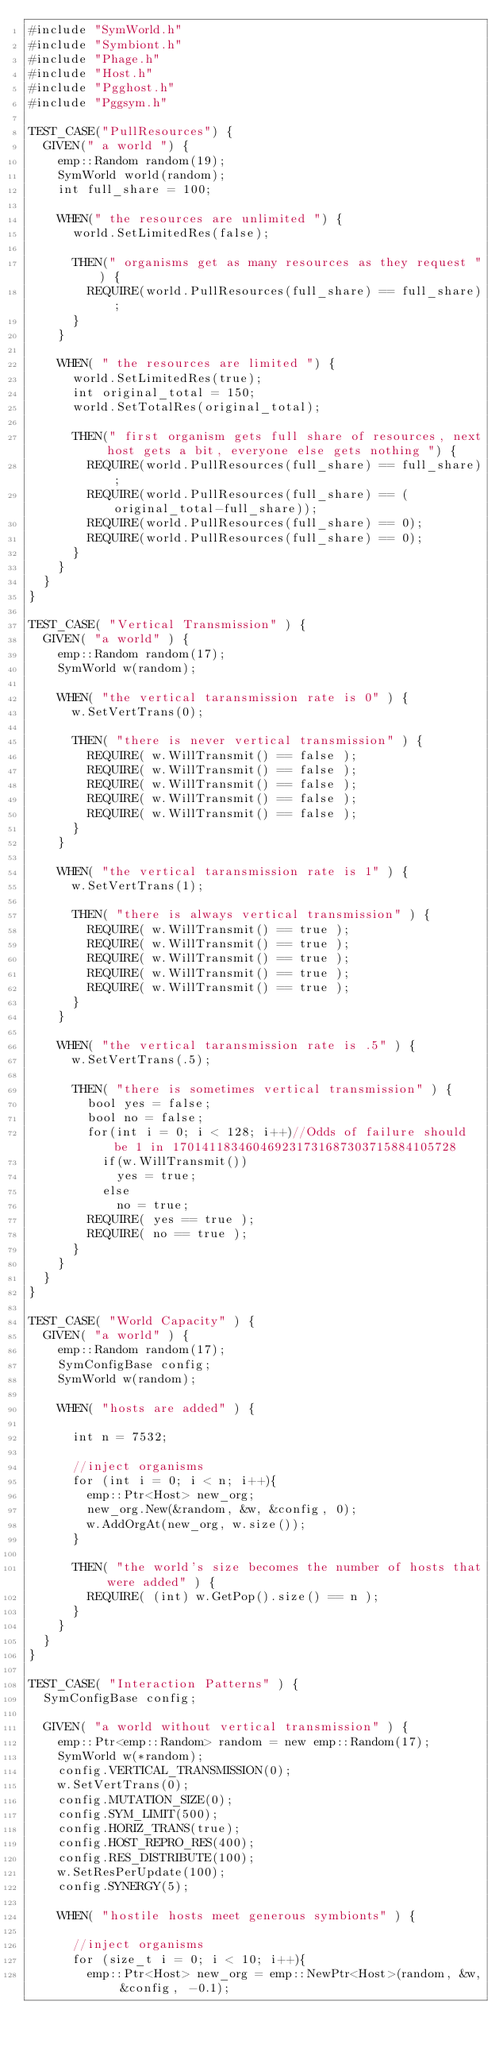Convert code to text. <code><loc_0><loc_0><loc_500><loc_500><_C++_>#include "SymWorld.h"
#include "Symbiont.h"
#include "Phage.h"
#include "Host.h"
#include "Pgghost.h"
#include "Pggsym.h"

TEST_CASE("PullResources") {
  GIVEN(" a world ") {
    emp::Random random(19);
    SymWorld world(random);
    int full_share = 100;

    WHEN(" the resources are unlimited ") {
      world.SetLimitedRes(false);

      THEN(" organisms get as many resources as they request ") {
        REQUIRE(world.PullResources(full_share) == full_share);
      }
    }

    WHEN( " the resources are limited ") {
      world.SetLimitedRes(true);
      int original_total = 150;
      world.SetTotalRes(original_total);

      THEN(" first organism gets full share of resources, next host gets a bit, everyone else gets nothing ") {
        REQUIRE(world.PullResources(full_share) == full_share);
        REQUIRE(world.PullResources(full_share) == (original_total-full_share));
        REQUIRE(world.PullResources(full_share) == 0);
        REQUIRE(world.PullResources(full_share) == 0);
      }
    }
  }
}

TEST_CASE( "Vertical Transmission" ) {
  GIVEN( "a world" ) {
    emp::Random random(17);
    SymWorld w(random);

    WHEN( "the vertical taransmission rate is 0" ) {
      w.SetVertTrans(0);

      THEN( "there is never vertical transmission" ) {
        REQUIRE( w.WillTransmit() == false );
        REQUIRE( w.WillTransmit() == false );
        REQUIRE( w.WillTransmit() == false );
        REQUIRE( w.WillTransmit() == false );
        REQUIRE( w.WillTransmit() == false );
      }
    }

    WHEN( "the vertical taransmission rate is 1" ) {
      w.SetVertTrans(1);

      THEN( "there is always vertical transmission" ) {
        REQUIRE( w.WillTransmit() == true );
        REQUIRE( w.WillTransmit() == true );
        REQUIRE( w.WillTransmit() == true );
        REQUIRE( w.WillTransmit() == true );
        REQUIRE( w.WillTransmit() == true );
      }
    }

    WHEN( "the vertical taransmission rate is .5" ) {
      w.SetVertTrans(.5);

      THEN( "there is sometimes vertical transmission" ) {
        bool yes = false;
        bool no = false;
        for(int i = 0; i < 128; i++)//Odds of failure should be 1 in 170141183460469231731687303715884105728
          if(w.WillTransmit())
            yes = true;
          else
            no = true;
        REQUIRE( yes == true );
        REQUIRE( no == true );
      }
    }
  }
}

TEST_CASE( "World Capacity" ) {
  GIVEN( "a world" ) {
    emp::Random random(17);
    SymConfigBase config;
    SymWorld w(random);

    WHEN( "hosts are added" ) {

      int n = 7532;

      //inject organisms
      for (int i = 0; i < n; i++){
        emp::Ptr<Host> new_org;
        new_org.New(&random, &w, &config, 0);
        w.AddOrgAt(new_org, w.size());
      }

      THEN( "the world's size becomes the number of hosts that were added" ) {
        REQUIRE( (int) w.GetPop().size() == n );
      }
    }
  }
}

TEST_CASE( "Interaction Patterns" ) {
  SymConfigBase config;

  GIVEN( "a world without vertical transmission" ) {
    emp::Ptr<emp::Random> random = new emp::Random(17);
    SymWorld w(*random);
    config.VERTICAL_TRANSMISSION(0);
    w.SetVertTrans(0);
    config.MUTATION_SIZE(0);
    config.SYM_LIMIT(500);
    config.HORIZ_TRANS(true);
    config.HOST_REPRO_RES(400);
    config.RES_DISTRIBUTE(100);
    w.SetResPerUpdate(100);
    config.SYNERGY(5);

    WHEN( "hostile hosts meet generous symbionts" ) {

      //inject organisms
      for (size_t i = 0; i < 10; i++){
        emp::Ptr<Host> new_org = emp::NewPtr<Host>(random, &w, &config, -0.1);</code> 